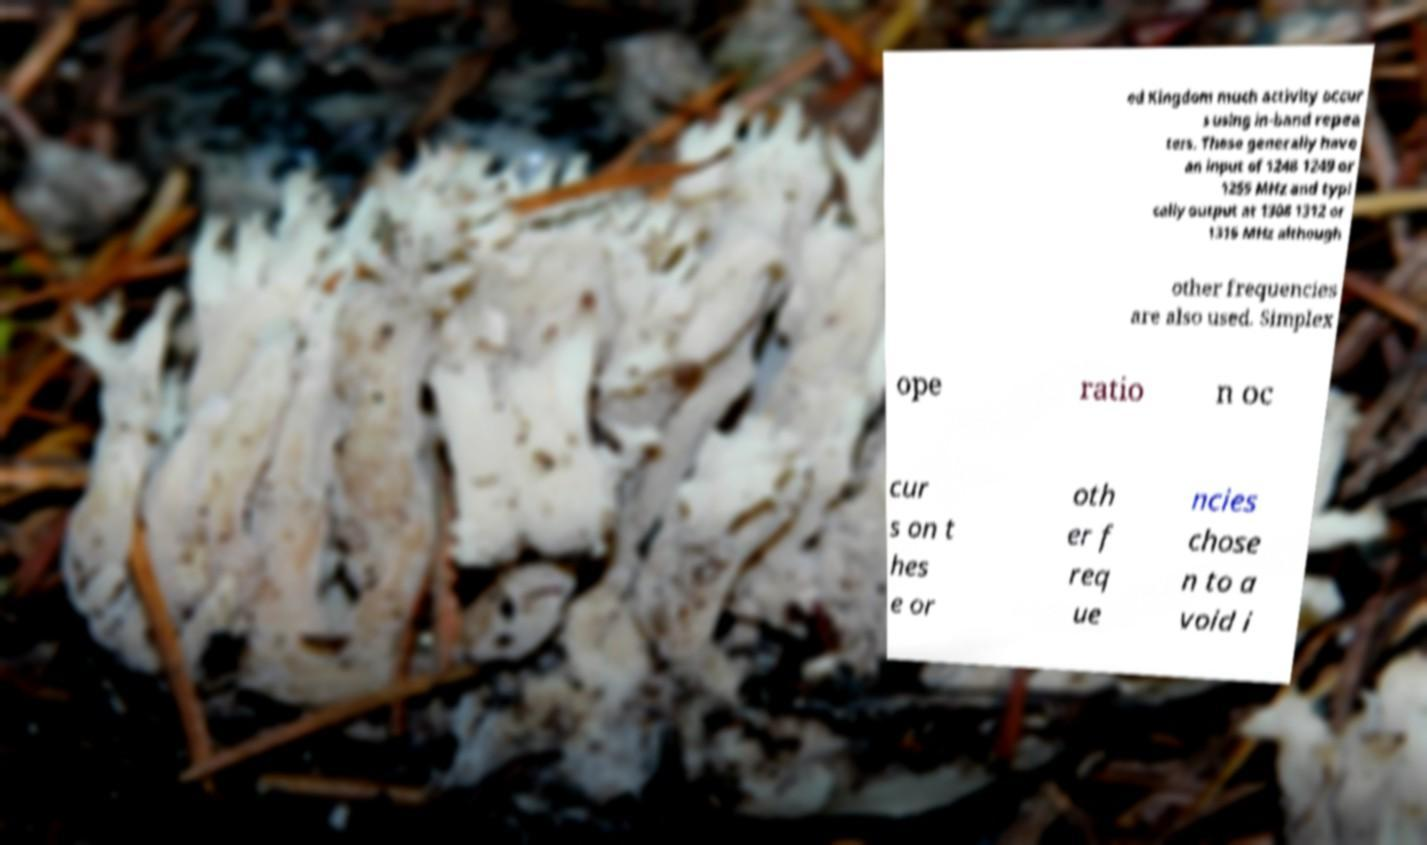Can you read and provide the text displayed in the image?This photo seems to have some interesting text. Can you extract and type it out for me? ed Kingdom much activity occur s using in-band repea ters. These generally have an input of 1248 1249 or 1255 MHz and typi cally output at 1308 1312 or 1316 MHz although other frequencies are also used. Simplex ope ratio n oc cur s on t hes e or oth er f req ue ncies chose n to a void i 